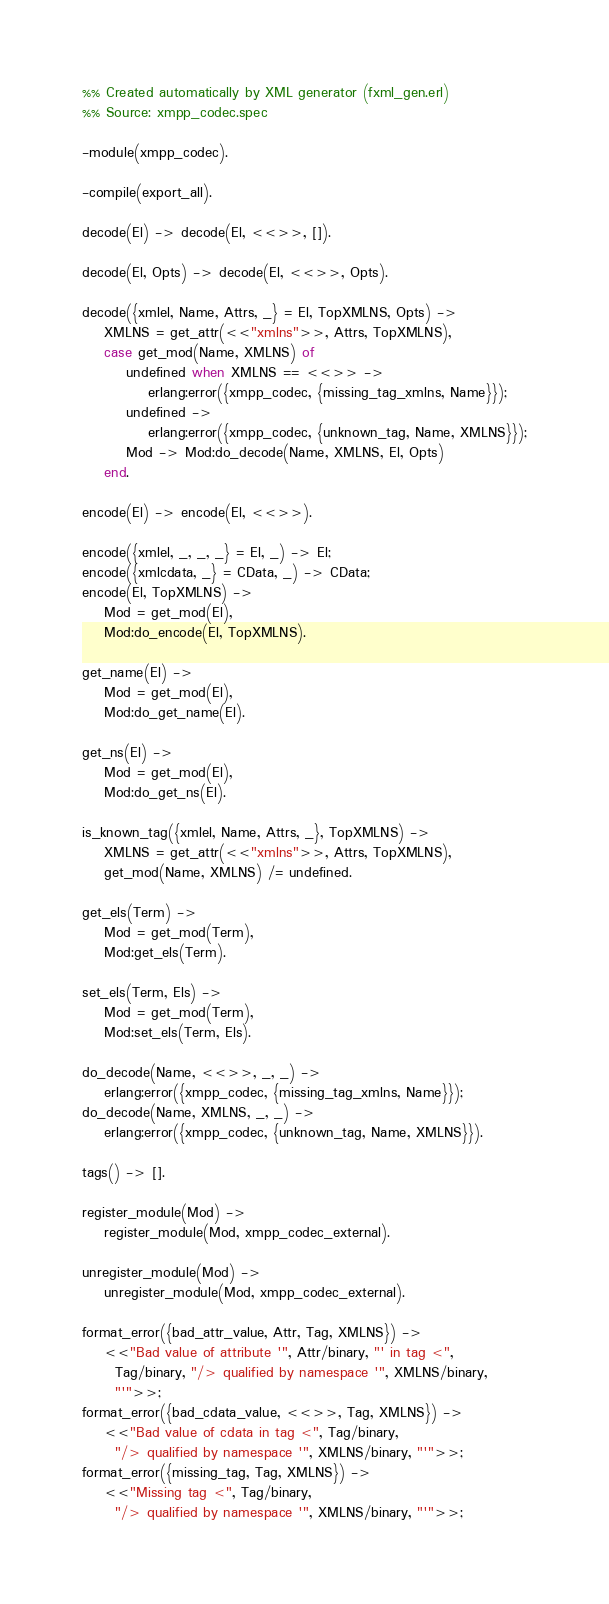Convert code to text. <code><loc_0><loc_0><loc_500><loc_500><_Erlang_>%% Created automatically by XML generator (fxml_gen.erl)
%% Source: xmpp_codec.spec

-module(xmpp_codec).

-compile(export_all).

decode(El) -> decode(El, <<>>, []).

decode(El, Opts) -> decode(El, <<>>, Opts).

decode({xmlel, Name, Attrs, _} = El, TopXMLNS, Opts) ->
    XMLNS = get_attr(<<"xmlns">>, Attrs, TopXMLNS),
    case get_mod(Name, XMLNS) of
        undefined when XMLNS == <<>> ->
            erlang:error({xmpp_codec, {missing_tag_xmlns, Name}});
        undefined ->
            erlang:error({xmpp_codec, {unknown_tag, Name, XMLNS}});
        Mod -> Mod:do_decode(Name, XMLNS, El, Opts)
    end.

encode(El) -> encode(El, <<>>).

encode({xmlel, _, _, _} = El, _) -> El;
encode({xmlcdata, _} = CData, _) -> CData;
encode(El, TopXMLNS) ->
    Mod = get_mod(El),
    Mod:do_encode(El, TopXMLNS).

get_name(El) ->
    Mod = get_mod(El),
    Mod:do_get_name(El).

get_ns(El) ->
    Mod = get_mod(El),
    Mod:do_get_ns(El).

is_known_tag({xmlel, Name, Attrs, _}, TopXMLNS) ->
    XMLNS = get_attr(<<"xmlns">>, Attrs, TopXMLNS),
    get_mod(Name, XMLNS) /= undefined.

get_els(Term) ->
    Mod = get_mod(Term),
    Mod:get_els(Term).

set_els(Term, Els) ->
    Mod = get_mod(Term),
    Mod:set_els(Term, Els).

do_decode(Name, <<>>, _, _) ->
    erlang:error({xmpp_codec, {missing_tag_xmlns, Name}});
do_decode(Name, XMLNS, _, _) ->
    erlang:error({xmpp_codec, {unknown_tag, Name, XMLNS}}).

tags() -> [].

register_module(Mod) ->
    register_module(Mod, xmpp_codec_external).

unregister_module(Mod) ->
    unregister_module(Mod, xmpp_codec_external).

format_error({bad_attr_value, Attr, Tag, XMLNS}) ->
    <<"Bad value of attribute '", Attr/binary, "' in tag <",
      Tag/binary, "/> qualified by namespace '", XMLNS/binary,
      "'">>;
format_error({bad_cdata_value, <<>>, Tag, XMLNS}) ->
    <<"Bad value of cdata in tag <", Tag/binary,
      "/> qualified by namespace '", XMLNS/binary, "'">>;
format_error({missing_tag, Tag, XMLNS}) ->
    <<"Missing tag <", Tag/binary,
      "/> qualified by namespace '", XMLNS/binary, "'">>;</code> 